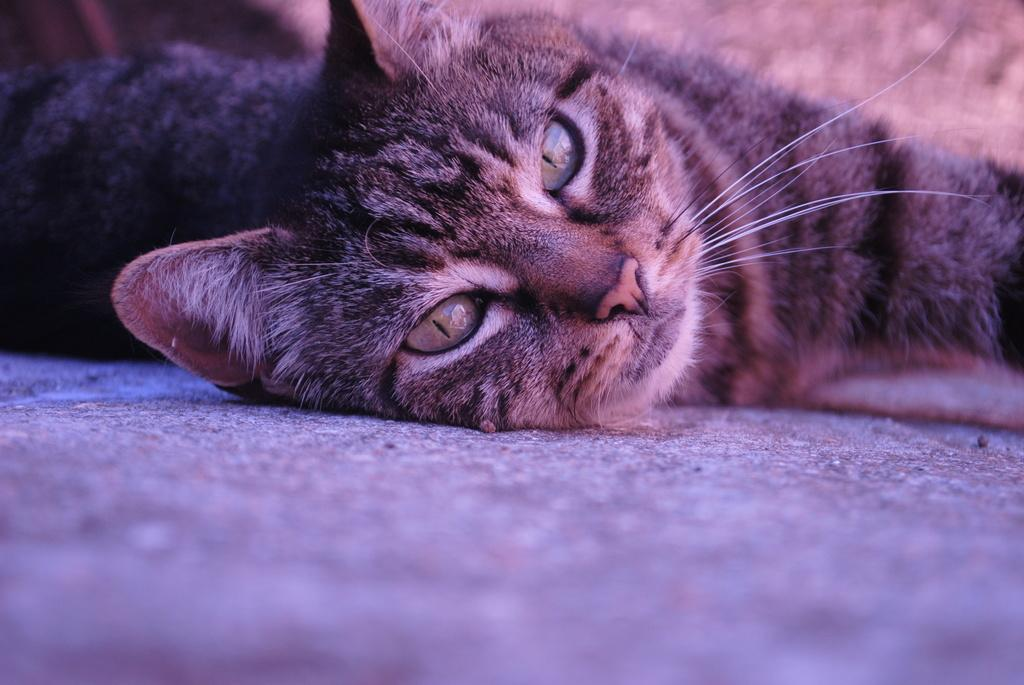What type of animal is in the image? There is a cat in the image. What is the cat doing in the image? The cat is laying on the ground. What color is the cat in the image? The cat is grey in color. What type of house can be seen in the background of the image? There is no house present in the image; it only features a cat laying on the ground. 